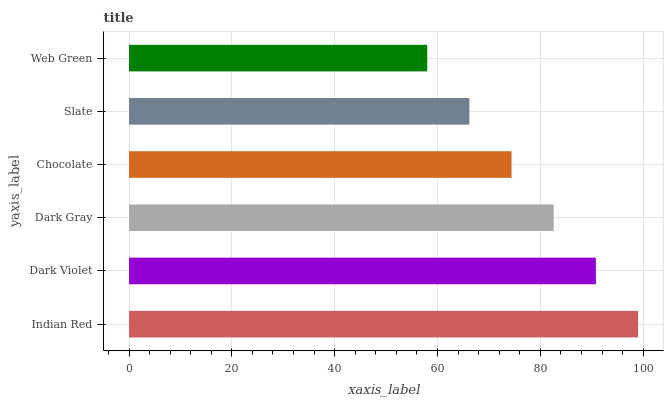Is Web Green the minimum?
Answer yes or no. Yes. Is Indian Red the maximum?
Answer yes or no. Yes. Is Dark Violet the minimum?
Answer yes or no. No. Is Dark Violet the maximum?
Answer yes or no. No. Is Indian Red greater than Dark Violet?
Answer yes or no. Yes. Is Dark Violet less than Indian Red?
Answer yes or no. Yes. Is Dark Violet greater than Indian Red?
Answer yes or no. No. Is Indian Red less than Dark Violet?
Answer yes or no. No. Is Dark Gray the high median?
Answer yes or no. Yes. Is Chocolate the low median?
Answer yes or no. Yes. Is Slate the high median?
Answer yes or no. No. Is Web Green the low median?
Answer yes or no. No. 